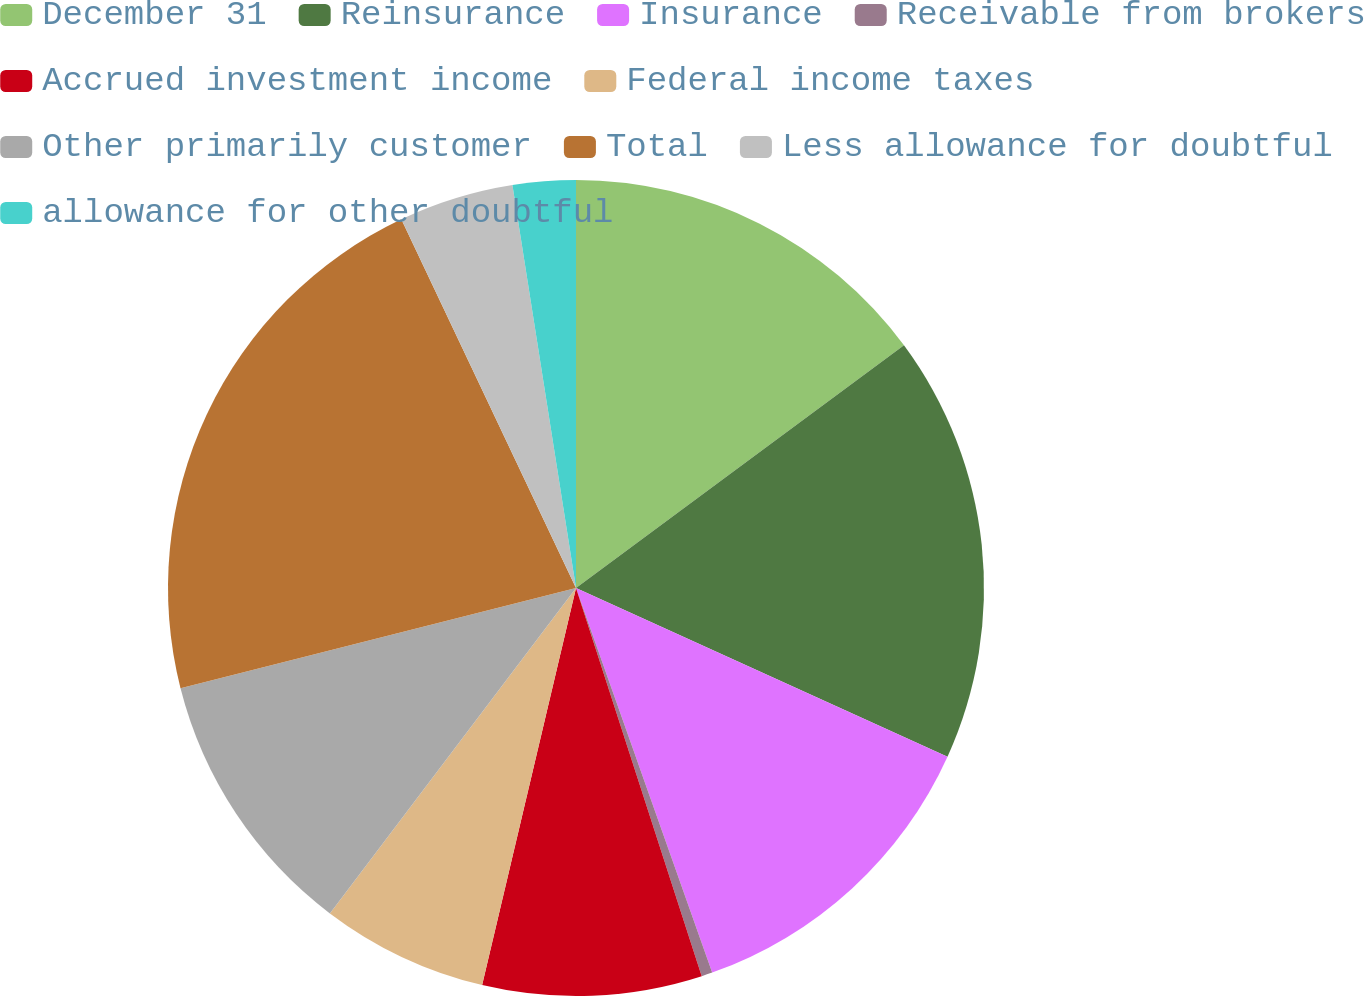Convert chart. <chart><loc_0><loc_0><loc_500><loc_500><pie_chart><fcel>December 31<fcel>Reinsurance<fcel>Insurance<fcel>Receivable from brokers<fcel>Accrued investment income<fcel>Federal income taxes<fcel>Other primarily customer<fcel>Total<fcel>Less allowance for doubtful<fcel>allowance for other doubtful<nl><fcel>14.86%<fcel>16.92%<fcel>12.8%<fcel>0.43%<fcel>8.68%<fcel>6.61%<fcel>10.74%<fcel>21.91%<fcel>4.55%<fcel>2.49%<nl></chart> 